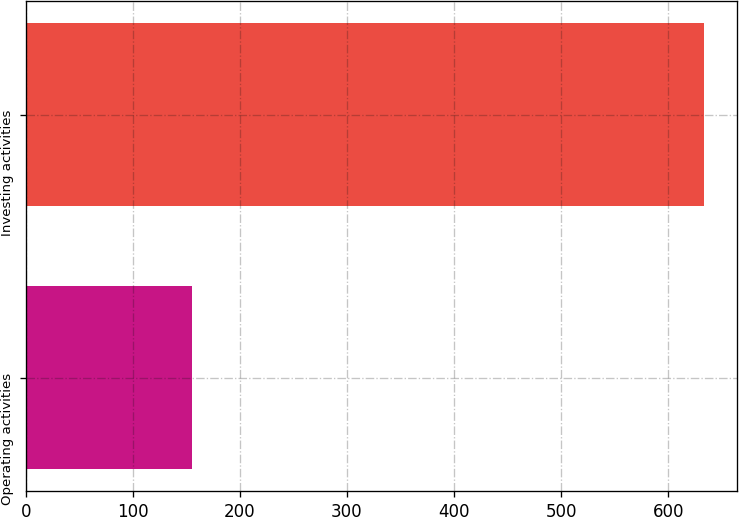<chart> <loc_0><loc_0><loc_500><loc_500><bar_chart><fcel>Operating activities<fcel>Investing activities<nl><fcel>155<fcel>633<nl></chart> 